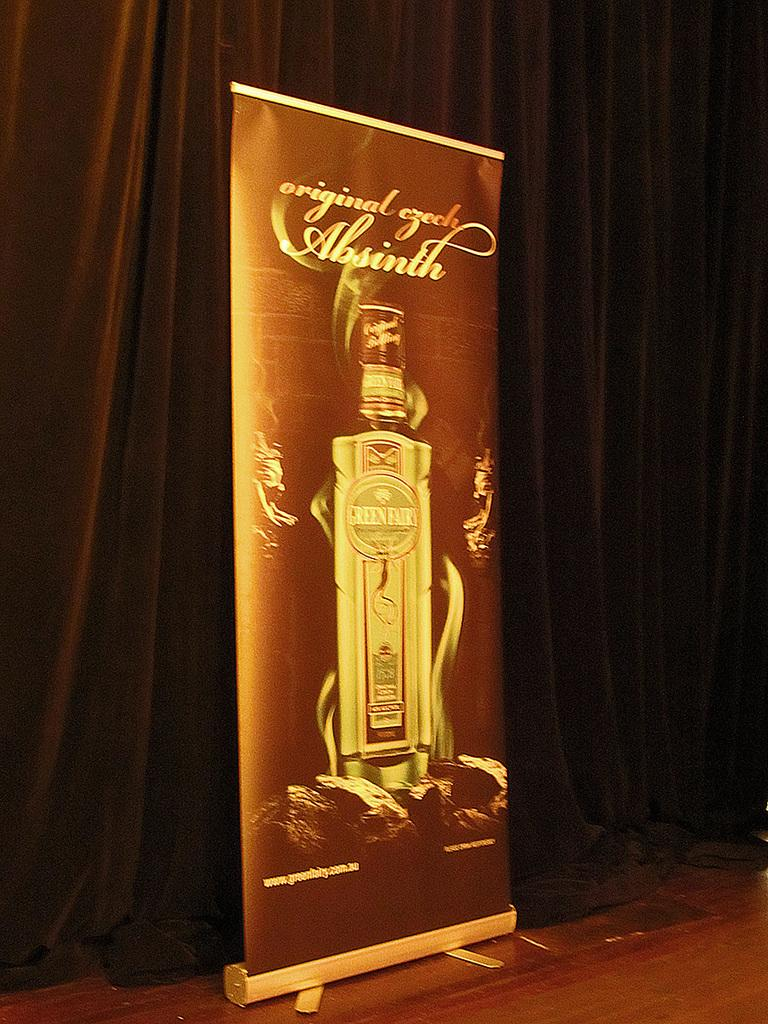<image>
Create a compact narrative representing the image presented. A poster for Original Czech Absinth is standing in front of a brown curtain 